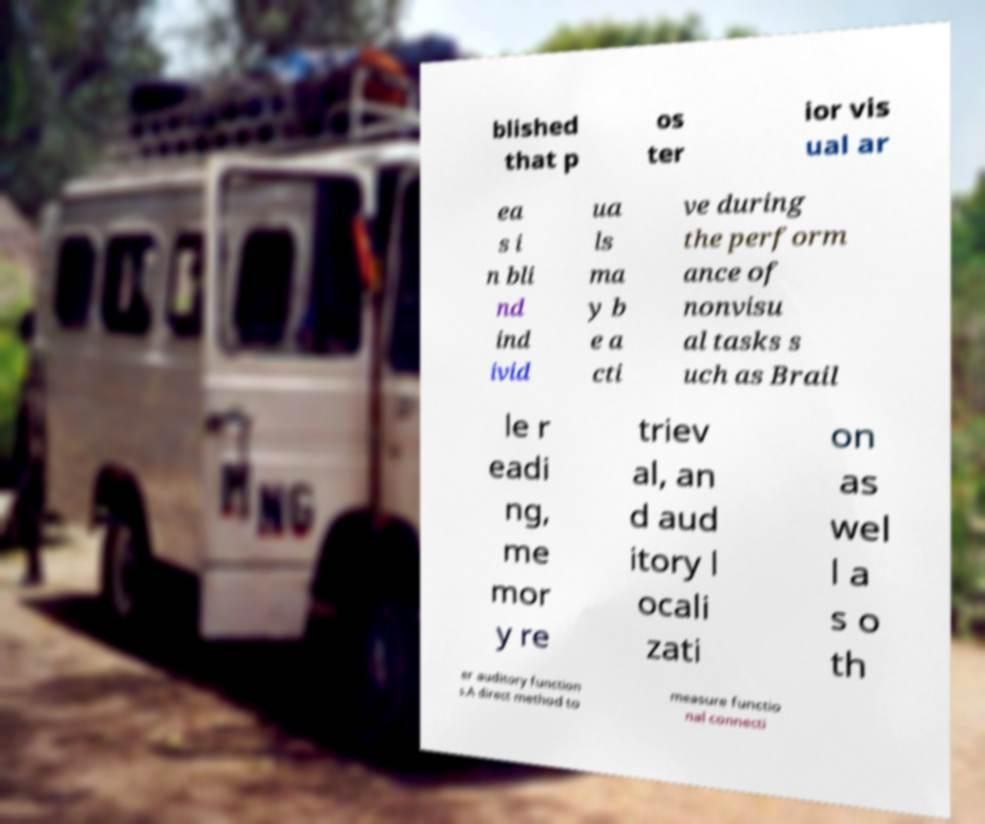Could you extract and type out the text from this image? blished that p os ter ior vis ual ar ea s i n bli nd ind ivid ua ls ma y b e a cti ve during the perform ance of nonvisu al tasks s uch as Brail le r eadi ng, me mor y re triev al, an d aud itory l ocali zati on as wel l a s o th er auditory function s.A direct method to measure functio nal connecti 